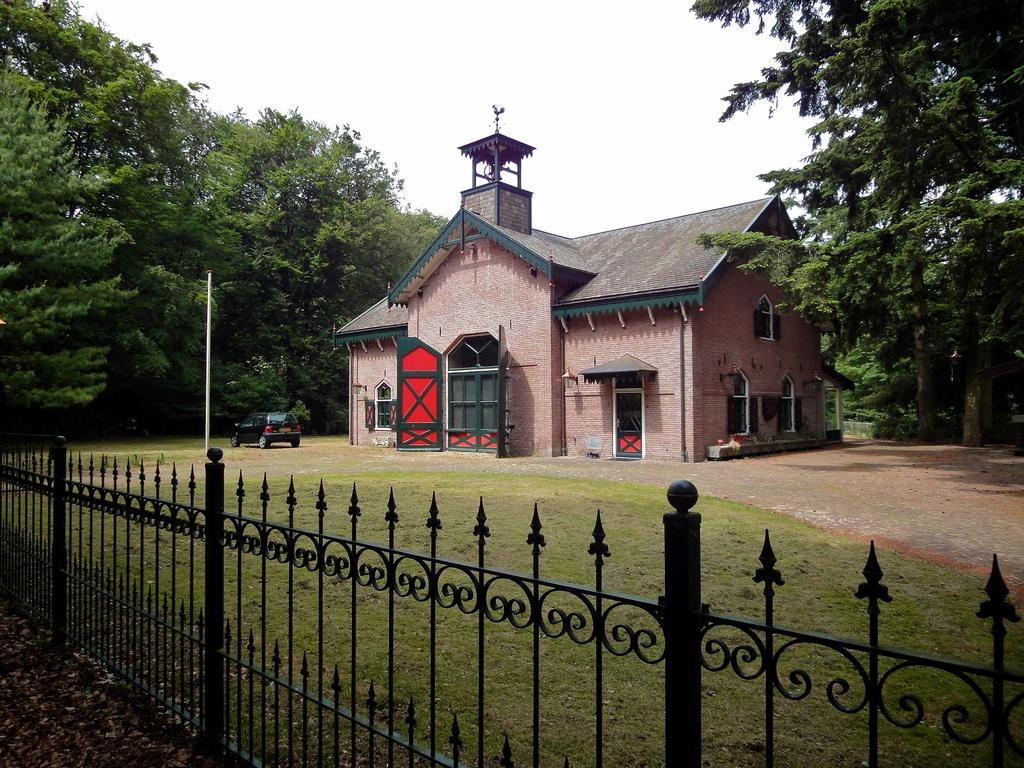What is located at the bottom of the image? There is a fence at the bottom of the image. What type of vegetation is present on the ground? Grass is present on the ground. What type of vehicle can be seen in the image? There is a car in the image. What architectural feature is visible in the image? A pole is visible in the image. What type of building is present in the image? There is a house in the image. What features are present on the house? Doors and windows are present in the house. What else can be seen in the image besides the house and car? Trees and the sky are visible in the image. What type of cherry is being used to fuel the flame in the image? There is no cherry or flame present in the image. How does the house express its hate for the car in the image? The image does not depict any emotions or interactions between the house and the car, so it cannot be determined if the house expresses any hate. 